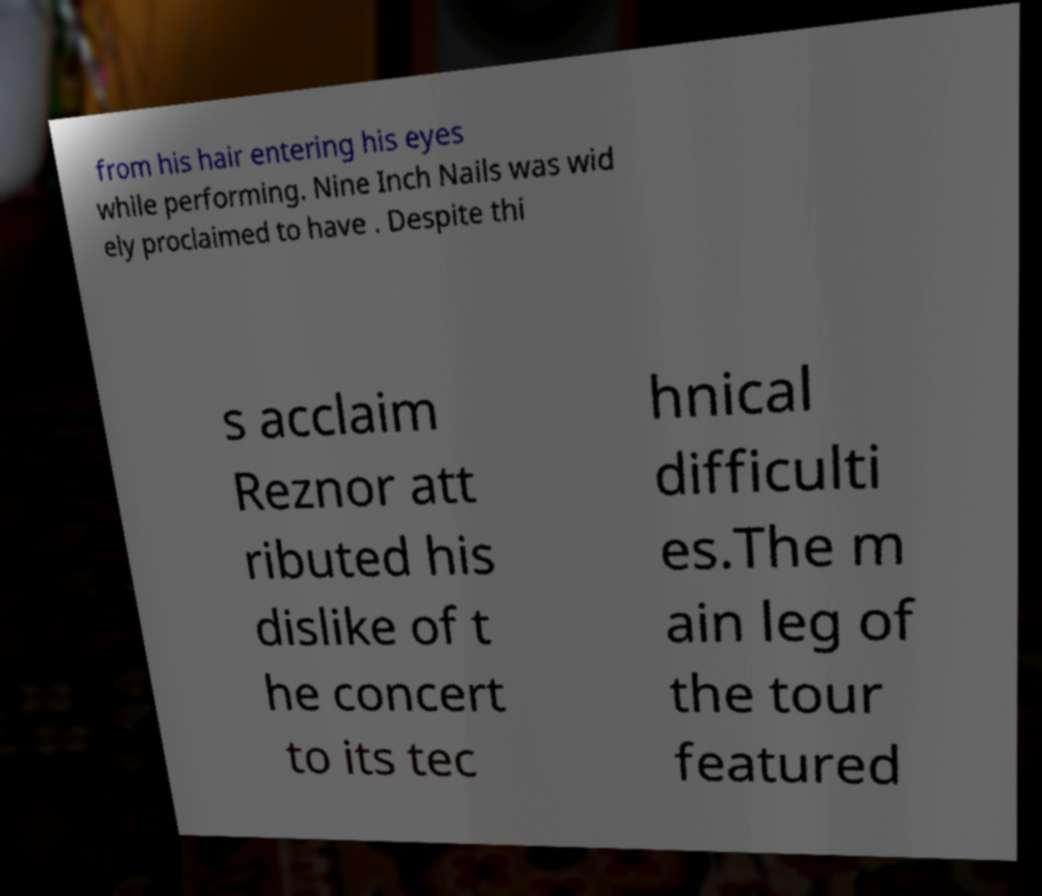Could you extract and type out the text from this image? from his hair entering his eyes while performing. Nine Inch Nails was wid ely proclaimed to have . Despite thi s acclaim Reznor att ributed his dislike of t he concert to its tec hnical difficulti es.The m ain leg of the tour featured 